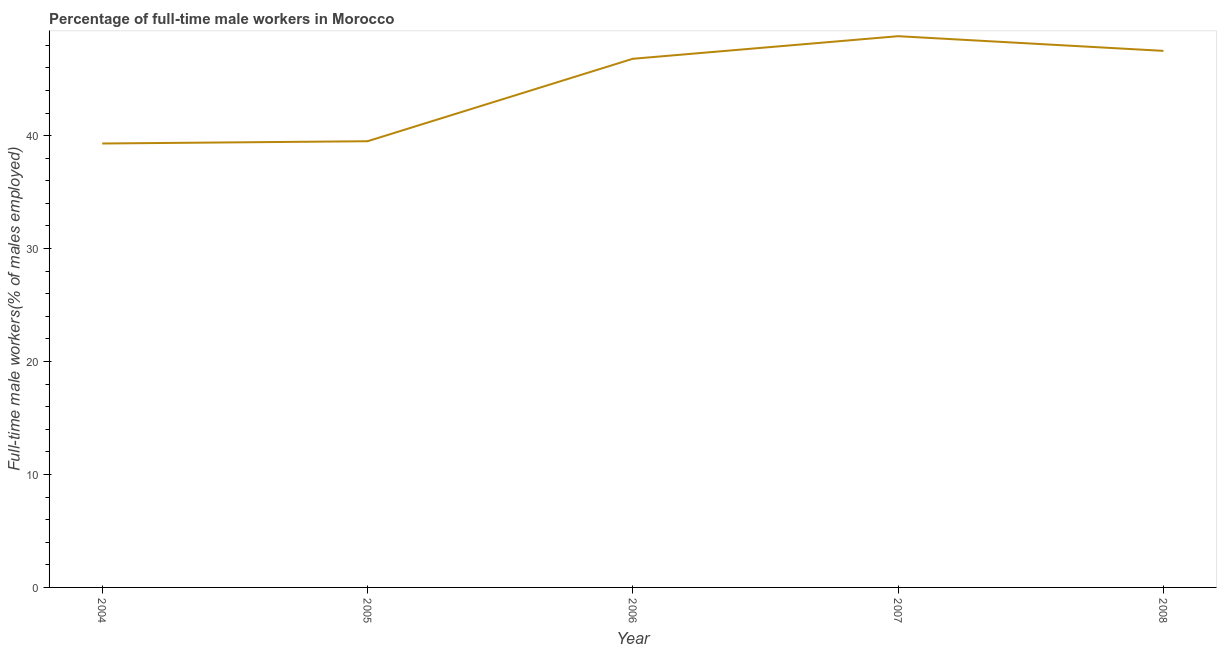What is the percentage of full-time male workers in 2004?
Ensure brevity in your answer.  39.3. Across all years, what is the maximum percentage of full-time male workers?
Your answer should be compact. 48.8. Across all years, what is the minimum percentage of full-time male workers?
Keep it short and to the point. 39.3. What is the sum of the percentage of full-time male workers?
Make the answer very short. 221.9. What is the difference between the percentage of full-time male workers in 2004 and 2007?
Ensure brevity in your answer.  -9.5. What is the average percentage of full-time male workers per year?
Your answer should be compact. 44.38. What is the median percentage of full-time male workers?
Offer a terse response. 46.8. What is the ratio of the percentage of full-time male workers in 2004 to that in 2007?
Give a very brief answer. 0.81. What is the difference between the highest and the second highest percentage of full-time male workers?
Your answer should be compact. 1.3. Is the sum of the percentage of full-time male workers in 2005 and 2008 greater than the maximum percentage of full-time male workers across all years?
Provide a succinct answer. Yes. What is the difference between the highest and the lowest percentage of full-time male workers?
Give a very brief answer. 9.5. In how many years, is the percentage of full-time male workers greater than the average percentage of full-time male workers taken over all years?
Offer a very short reply. 3. How many lines are there?
Your answer should be very brief. 1. What is the difference between two consecutive major ticks on the Y-axis?
Your answer should be compact. 10. Are the values on the major ticks of Y-axis written in scientific E-notation?
Offer a very short reply. No. Does the graph contain any zero values?
Offer a very short reply. No. What is the title of the graph?
Keep it short and to the point. Percentage of full-time male workers in Morocco. What is the label or title of the Y-axis?
Your response must be concise. Full-time male workers(% of males employed). What is the Full-time male workers(% of males employed) of 2004?
Give a very brief answer. 39.3. What is the Full-time male workers(% of males employed) in 2005?
Make the answer very short. 39.5. What is the Full-time male workers(% of males employed) in 2006?
Your answer should be very brief. 46.8. What is the Full-time male workers(% of males employed) of 2007?
Offer a terse response. 48.8. What is the Full-time male workers(% of males employed) in 2008?
Your answer should be very brief. 47.5. What is the difference between the Full-time male workers(% of males employed) in 2005 and 2006?
Your response must be concise. -7.3. What is the difference between the Full-time male workers(% of males employed) in 2006 and 2008?
Make the answer very short. -0.7. What is the difference between the Full-time male workers(% of males employed) in 2007 and 2008?
Your answer should be compact. 1.3. What is the ratio of the Full-time male workers(% of males employed) in 2004 to that in 2005?
Make the answer very short. 0.99. What is the ratio of the Full-time male workers(% of males employed) in 2004 to that in 2006?
Provide a short and direct response. 0.84. What is the ratio of the Full-time male workers(% of males employed) in 2004 to that in 2007?
Offer a terse response. 0.81. What is the ratio of the Full-time male workers(% of males employed) in 2004 to that in 2008?
Make the answer very short. 0.83. What is the ratio of the Full-time male workers(% of males employed) in 2005 to that in 2006?
Ensure brevity in your answer.  0.84. What is the ratio of the Full-time male workers(% of males employed) in 2005 to that in 2007?
Your answer should be compact. 0.81. What is the ratio of the Full-time male workers(% of males employed) in 2005 to that in 2008?
Offer a terse response. 0.83. What is the ratio of the Full-time male workers(% of males employed) in 2006 to that in 2007?
Make the answer very short. 0.96. What is the ratio of the Full-time male workers(% of males employed) in 2007 to that in 2008?
Make the answer very short. 1.03. 